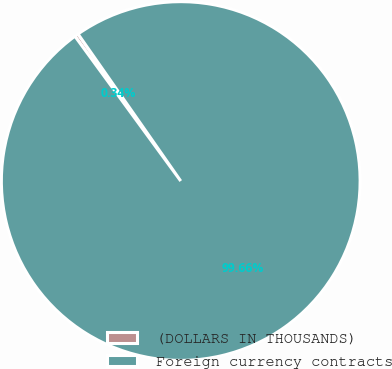<chart> <loc_0><loc_0><loc_500><loc_500><pie_chart><fcel>(DOLLARS IN THOUSANDS)<fcel>Foreign currency contracts<nl><fcel>0.34%<fcel>99.66%<nl></chart> 